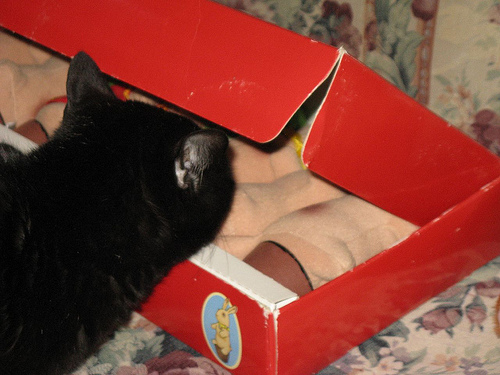<image>
Is there a cat in the box? No. The cat is not contained within the box. These objects have a different spatial relationship. 